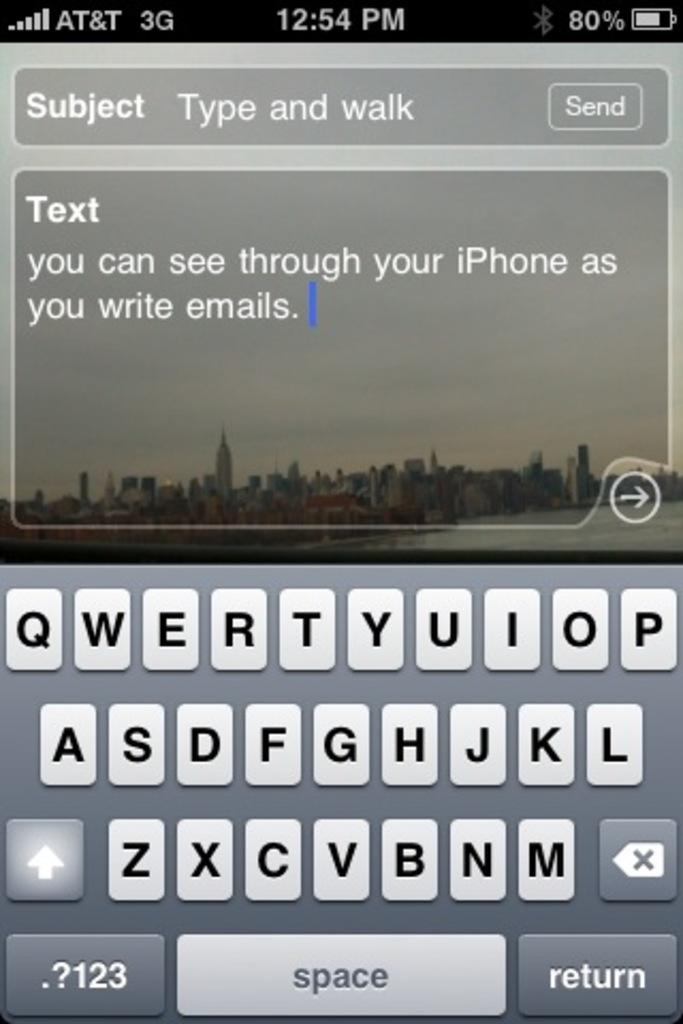<image>
Summarize the visual content of the image. Someone is writing text about the subject Type and Walk on an AT&T smartphone. 